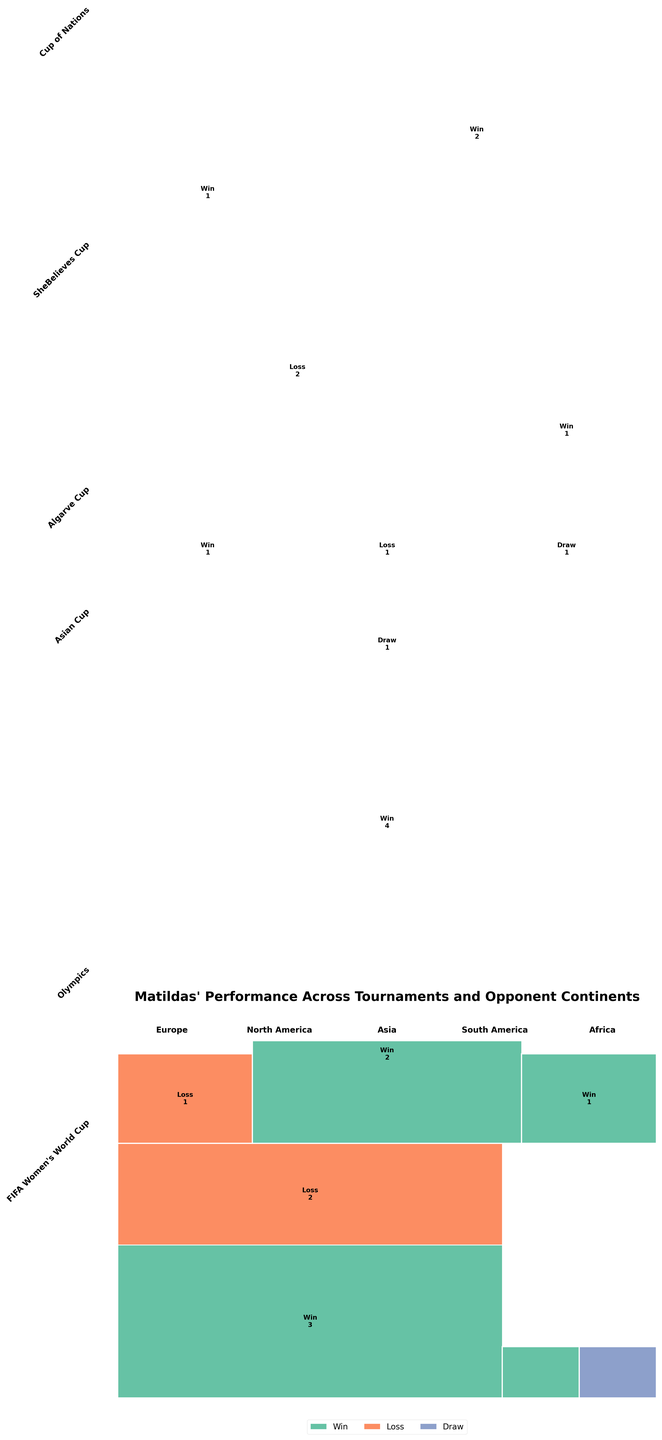What's the title of the plot? The title can be found at the top of the figure. It summarizes what the plot represents.
Answer: Matildas' Performance Across Tournaments and Opponent Continents Which continent did the Matildas win most matches against in the Asian Cup? The data section of the plot includes a rectangle representing performance in the Asian Cup, with different colors for each result. Find the continent Asia, then observe and count the 'Win' segments.
Answer: Asia How many wins did the Matildas achieve in the Cup of Nations? Look for the "Cup of Nations" section and spot the 'Win' segments across continents. Sum the counts, which are labeled inside the rectangles.
Answer: 3 Comparing Europe and Asia in the FIFA Women's World Cup, which continent has more losses for the Matildas? Look at the FIFA Women's World Cup section of the plot and compare the 'Loss' sections for Europe and Asia. Count the rectangles labeled 'Loss' in each and compare.
Answer: Europe Is there any continent where the Matildas had no matches ending in a draw? Review all the sections and check for any continents without any rectangles labeled 'Draw' in any tournament.
Answer: South America, Africa Which tournament shows the highest number of draws for the Matildas? Look at all portions of the plot corresponding to different tournaments and count the 'Draw' sections. The tournament with the highest sum of 'Draw' counts holds the answer.
Answer: Asian Cup What's the combined number of wins the Matildas had against Europe in all tournaments? Sum up all the 'Win' counts associated with Europe across the tournaments within the plot. Check each tournament and add the numbers.
Answer: 4 Which opponent continent did the Matildas face the least in all tournaments? Identify the continents by checking the number of data points related to each. The one with the least number of segments will be the answer.
Answer: Africa How many losses did the Matildas have in the SheBelieves Cup? Focus on the SheBelieves Cup section and count the segments labeled as 'Loss'.
Answer: 2 Which tournament shows the highest variation in results (win, draw, loss) against Europe? Observe each tournament's section corresponding to matches against Europe and note the variation (presence of different colors). The one with all three types (win, draw, loss) or the most distinct results is the answer.
Answer: FIAF Women's World Cup 